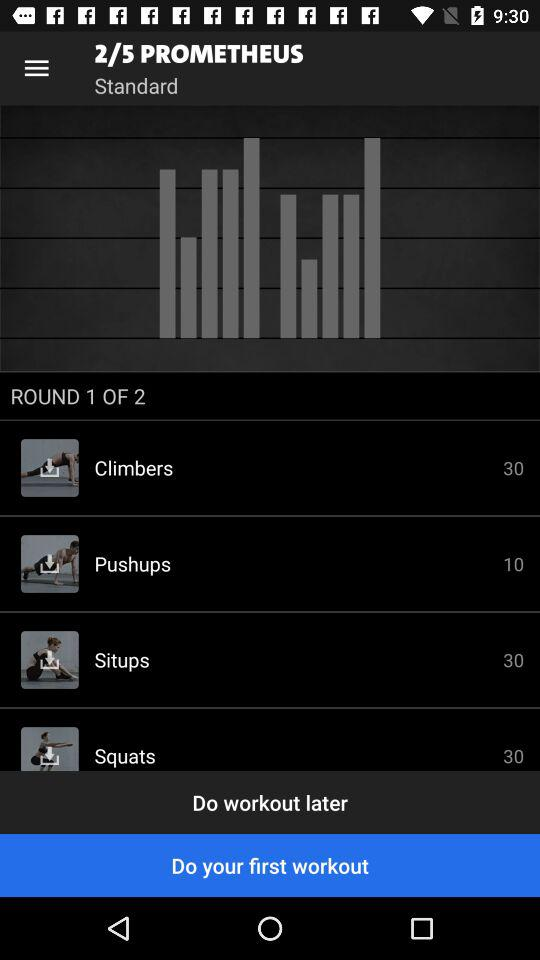How many rounds in total are there? There are total 2 rounds. 